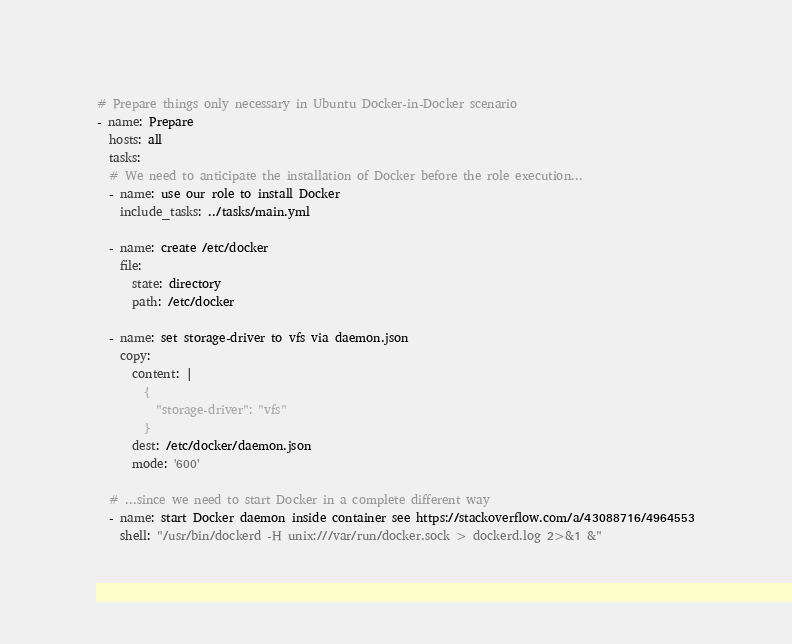Convert code to text. <code><loc_0><loc_0><loc_500><loc_500><_YAML_># Prepare things only necessary in Ubuntu Docker-in-Docker scenario
- name: Prepare
  hosts: all
  tasks:
  # We need to anticipate the installation of Docker before the role execution...
  - name: use our role to install Docker
    include_tasks: ../tasks/main.yml

  - name: create /etc/docker
    file:
      state: directory
      path: /etc/docker

  - name: set storage-driver to vfs via daemon.json
    copy:
      content: |
        {
          "storage-driver": "vfs"
        }
      dest: /etc/docker/daemon.json
      mode: '600'

  # ...since we need to start Docker in a complete different way
  - name: start Docker daemon inside container see https://stackoverflow.com/a/43088716/4964553
    shell: "/usr/bin/dockerd -H unix:///var/run/docker.sock > dockerd.log 2>&1 &"
</code> 